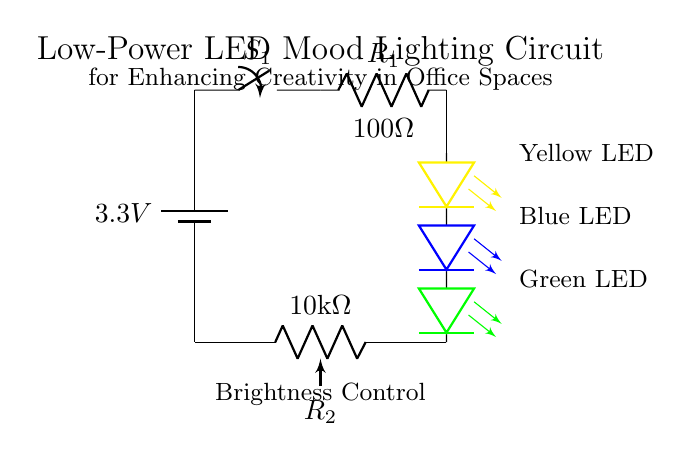What is the voltage of the power supply? The power supply is represented by a battery symbol with a label indicating a voltage of 3.3 volts. Therefore, the voltage of the power supply is labeled directly in the diagram.
Answer: 3.3 volts What type of switch is used in the circuit? The switch in the circuit is marked with the label 'S1' and is a simple on/off switch depicted in the diagram. The circuit's functionality relies on this switch to control the power to the LEDs.
Answer: Switch How many LEDs are incorporated in this circuit? The circuit has an array of three LEDs, each indicated with a different color in the schematic. They are labeled as yellow, blue, and green LEDs, clearly representing a total of three LEDs utilized in the lighting design.
Answer: Three What is the purpose of the resistor labeled R1? The resistor R1 is connected in series with the LEDs, and its role is to limit the current flowing through the LEDs to prevent them from drawing too much current, which could damage them. The circuit indicates this function directly through the presence and labeling of R1.
Answer: Current limiting How does the potentiometer R2 affect the brightness of the LEDs? The potentiometer R2 serves as a variable resistor within the circuit, allowing the user to adjust the resistance. This adjustment changes the current flowing through the LEDs. Lower resistance increases current and brightness, while higher resistance decreases current and dims the LEDs. By looking at R2's connection to the power supply and LED array, this relationship becomes apparent.
Answer: Adjusts brightness What is the significance of the different LED colors in this circuit? The different colors of the LEDs (yellow, blue, green) provide various light spectra that can influence mood and creativity. Color psychology suggests that different colors can evoke specific emotions, thus enhancing creativity in an office setting. This understanding relies on both the color code depicted and knowledge of how color impacts mood.
Answer: Mood enhancement 